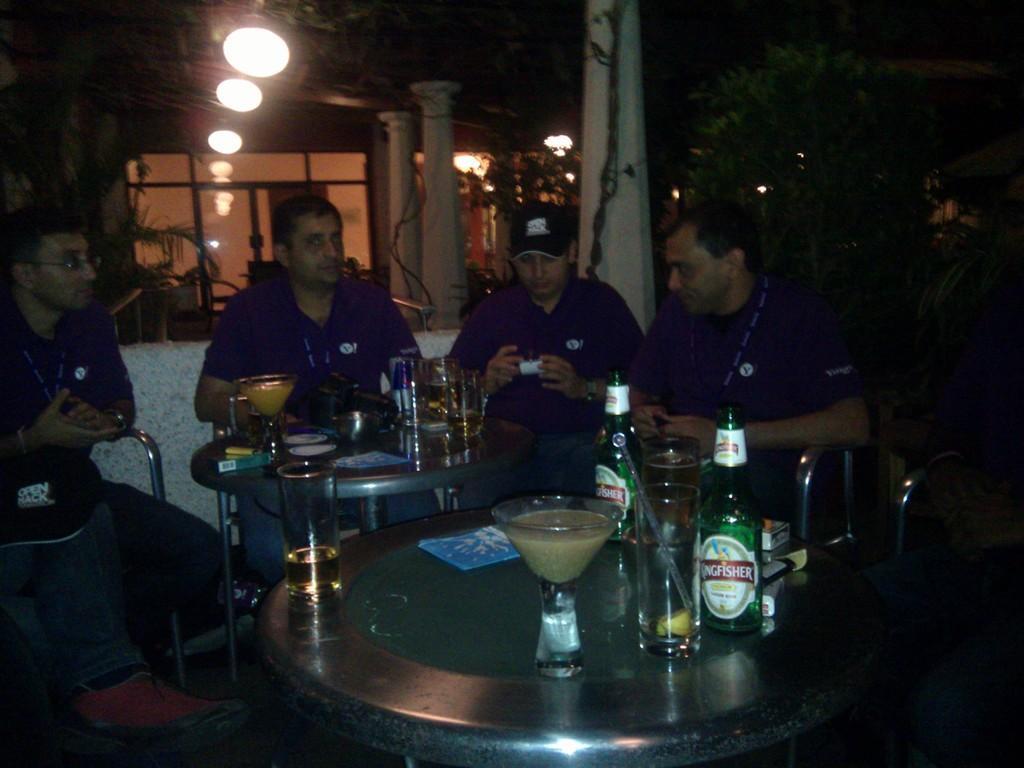Describe this image in one or two sentences. In this image I can see four persons wearing blue t shirts are sitting on chairs around a table. On the table I can see few glasses, few bottles and few other objects. I can see one of the person is wearing a black colored hat. In the background I can see few lights, few dollars and few trees. 